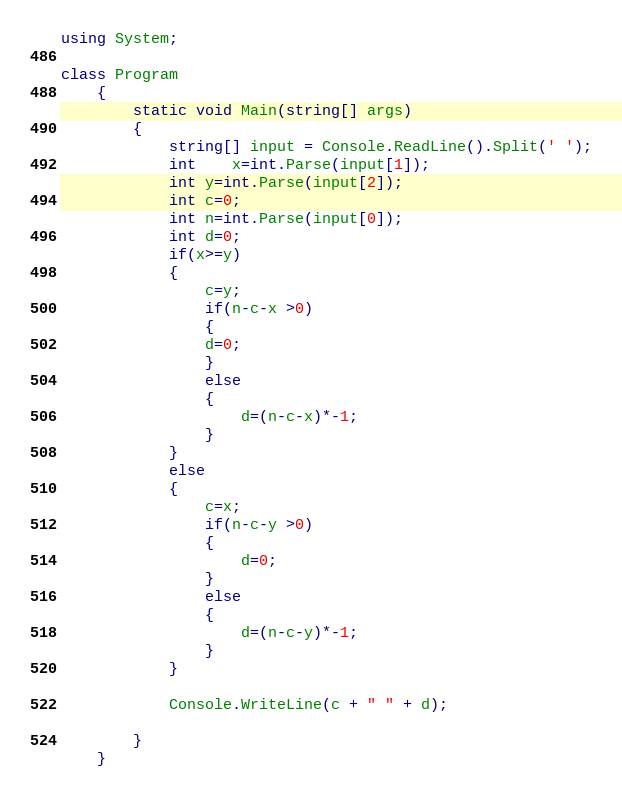Convert code to text. <code><loc_0><loc_0><loc_500><loc_500><_C#_>using System;

class Program
	{
		static void Main(string[] args)
		{
			string[] input = Console.ReadLine().Split(' ');
			int	x=int.Parse(input[1]);
			int y=int.Parse(input[2]);
			int c=0;
			int n=int.Parse(input[0]);
			int d=0;
			if(x>=y)
			{
				c=y;
				if(n-c-x >0)
				{
				d=0;
				}
				else
				{
					d=(n-c-x)*-1;
				}
			}
			else
			{
				c=x;
				if(n-c-y >0)
				{
					d=0;
				}
				else
				{
					d=(n-c-y)*-1;
				}
			}
 
			Console.WriteLine(c + " " + d);
			
		}
	}
</code> 